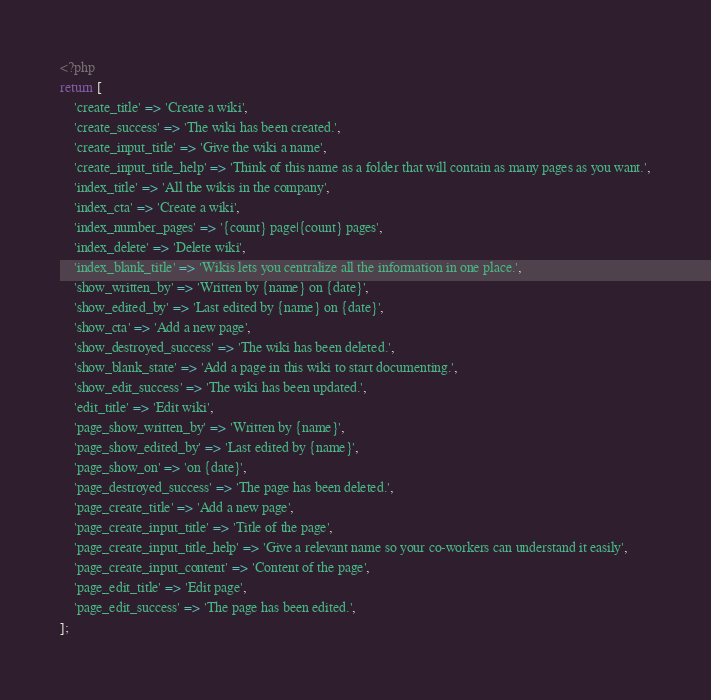Convert code to text. <code><loc_0><loc_0><loc_500><loc_500><_PHP_><?php
return [
    'create_title' => 'Create a wiki',
    'create_success' => 'The wiki has been created.',
    'create_input_title' => 'Give the wiki a name',
    'create_input_title_help' => 'Think of this name as a folder that will contain as many pages as you want.',
    'index_title' => 'All the wikis in the company',
    'index_cta' => 'Create a wiki',
    'index_number_pages' => '{count} page|{count} pages',
    'index_delete' => 'Delete wiki',
    'index_blank_title' => 'Wikis lets you centralize all the information in one place.',
    'show_written_by' => 'Written by {name} on {date}',
    'show_edited_by' => 'Last edited by {name} on {date}',
    'show_cta' => 'Add a new page',
    'show_destroyed_success' => 'The wiki has been deleted.',
    'show_blank_state' => 'Add a page in this wiki to start documenting.',
    'show_edit_success' => 'The wiki has been updated.',
    'edit_title' => 'Edit wiki',
    'page_show_written_by' => 'Written by {name}',
    'page_show_edited_by' => 'Last edited by {name}',
    'page_show_on' => 'on {date}',
    'page_destroyed_success' => 'The page has been deleted.',
    'page_create_title' => 'Add a new page',
    'page_create_input_title' => 'Title of the page',
    'page_create_input_title_help' => 'Give a relevant name so your co-workers can understand it easily',
    'page_create_input_content' => 'Content of the page',
    'page_edit_title' => 'Edit page',
    'page_edit_success' => 'The page has been edited.',
];
</code> 